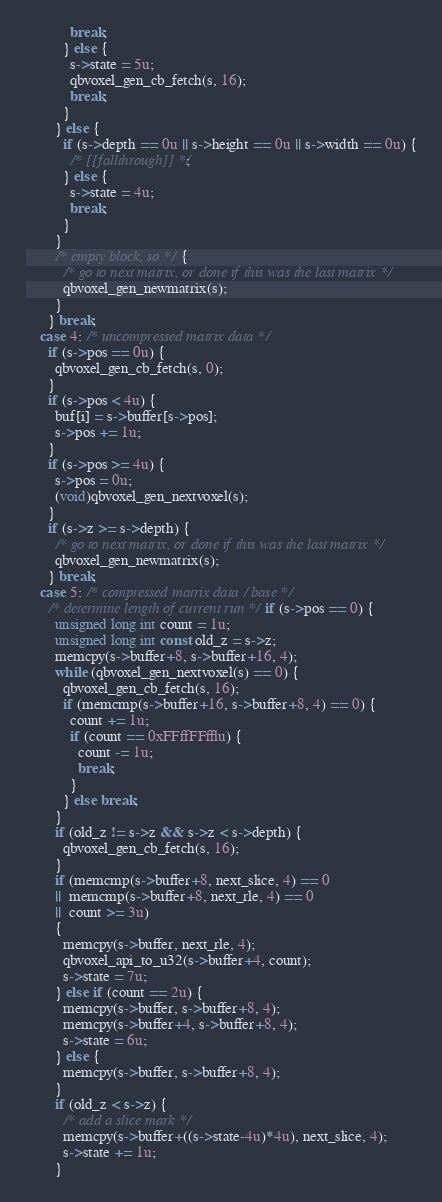Convert code to text. <code><loc_0><loc_0><loc_500><loc_500><_C_>            break;
          } else {
            s->state = 5u;
            qbvoxel_gen_cb_fetch(s, 16);
            break;
          }
        } else {
          if (s->depth == 0u || s->height == 0u || s->width == 0u) {
            /* [[fallthrough]] */;
          } else {
            s->state = 4u;
            break;
          }
        }
        /* empty block, so */{
          /* go to next matrix, or done if this was the last matrix */
          qbvoxel_gen_newmatrix(s);
        }
      } break;
    case 4: /* uncompressed matrix data */
      if (s->pos == 0u) {
        qbvoxel_gen_cb_fetch(s, 0);
      }
      if (s->pos < 4u) {
        buf[i] = s->buffer[s->pos];
        s->pos += 1u;
      }
      if (s->pos >= 4u) {
        s->pos = 0u;
        (void)qbvoxel_gen_nextvoxel(s);
      }
      if (s->z >= s->depth) {
        /* go to next matrix, or done if this was the last matrix */
        qbvoxel_gen_newmatrix(s);
      } break;
    case 5: /* compressed matrix data / base */
      /* determine length of current run */if (s->pos == 0) {
        unsigned long int count = 1u;
        unsigned long int const old_z = s->z;
        memcpy(s->buffer+8, s->buffer+16, 4);
        while (qbvoxel_gen_nextvoxel(s) == 0) {
          qbvoxel_gen_cb_fetch(s, 16);
          if (memcmp(s->buffer+16, s->buffer+8, 4) == 0) {
            count += 1u;
            if (count == 0xFFffFFfflu) {
              count -= 1u;
              break;
            }
          } else break;
        }
        if (old_z != s->z && s->z < s->depth) {
          qbvoxel_gen_cb_fetch(s, 16);
        }
        if (memcmp(s->buffer+8, next_slice, 4) == 0
        ||  memcmp(s->buffer+8, next_rle, 4) == 0
        ||  count >= 3u)
        {
          memcpy(s->buffer, next_rle, 4);
          qbvoxel_api_to_u32(s->buffer+4, count);
          s->state = 7u;
        } else if (count == 2u) {
          memcpy(s->buffer, s->buffer+8, 4);
          memcpy(s->buffer+4, s->buffer+8, 4);
          s->state = 6u;
        } else {
          memcpy(s->buffer, s->buffer+8, 4);
        }
        if (old_z < s->z) {
          /* add a slice mark */
          memcpy(s->buffer+((s->state-4u)*4u), next_slice, 4);
          s->state += 1u;
        }</code> 